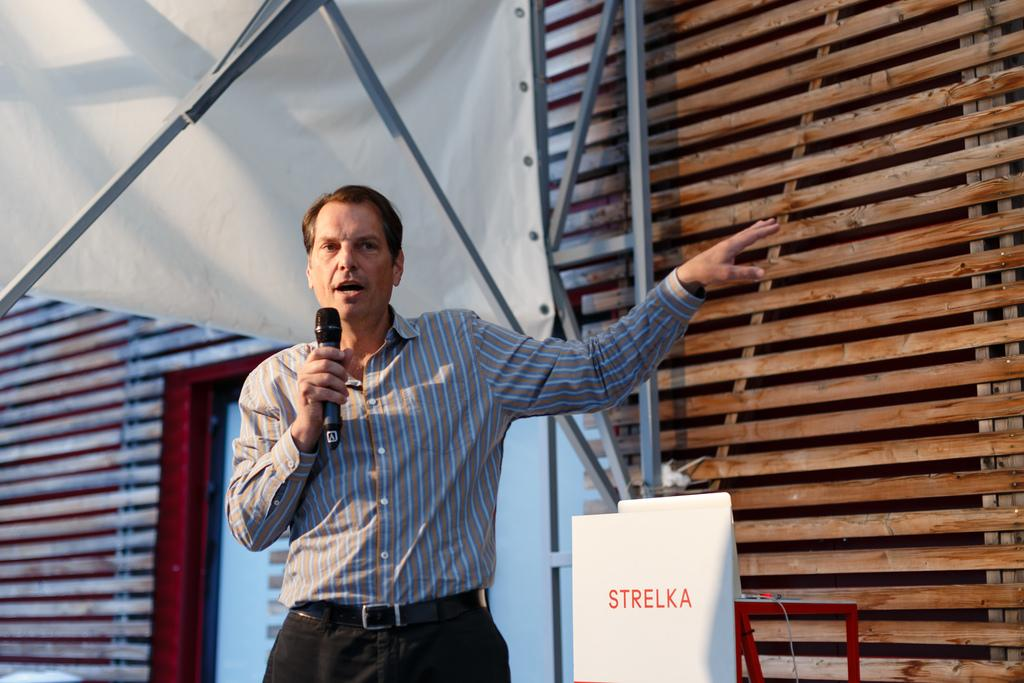What is present in the image? There is a man in the image. What is the man doing in the image? The man is standing and speaking. How is the man amplifying his voice in the image? The man is using a microphone to speak. Where are the porter and the stage located in the image? There is no porter or stage present in the image. How many chickens are visible in the image? There are no chickens visible in the image. 